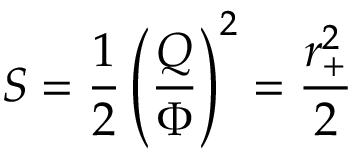Convert formula to latex. <formula><loc_0><loc_0><loc_500><loc_500>S = { \frac { 1 } { 2 } } \left ( { \frac { Q } { \Phi } } \right ) ^ { 2 } = { \frac { r _ { + } ^ { 2 } } { 2 } }</formula> 